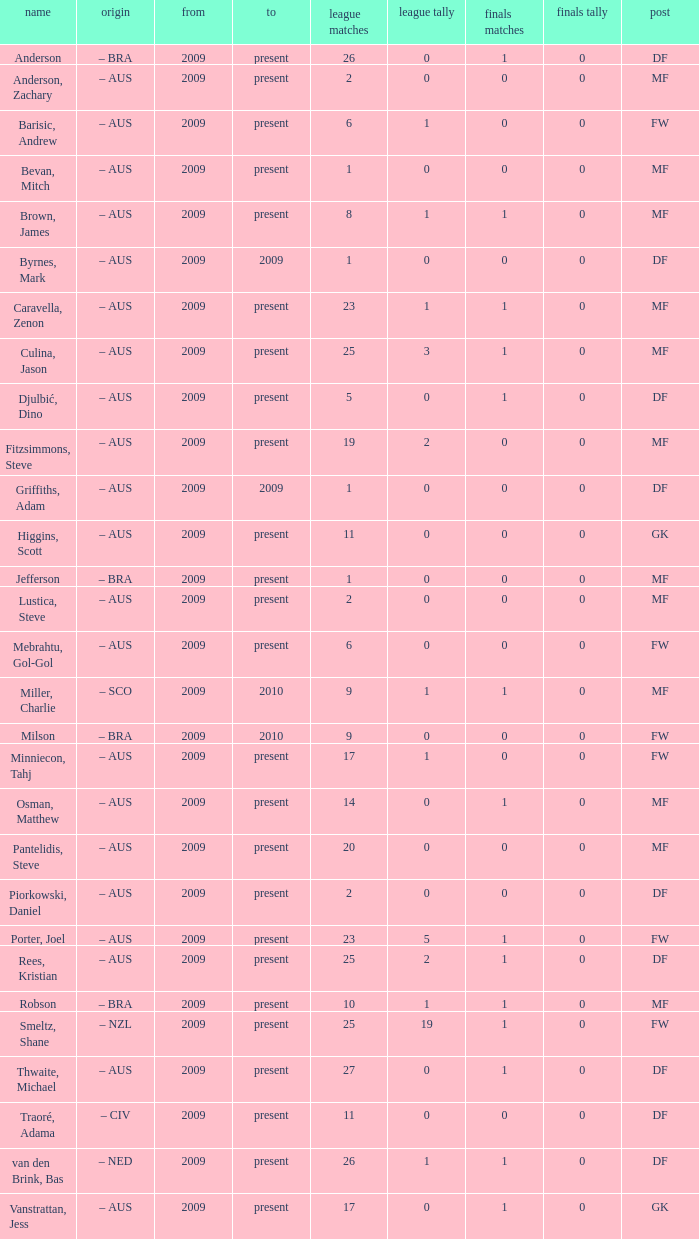Name the position for van den brink, bas DF. 